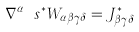Convert formula to latex. <formula><loc_0><loc_0><loc_500><loc_500>\nabla ^ { \alpha } \ s ^ { * } W _ { \alpha \beta \gamma \delta } = J ^ { * } _ { \beta \gamma \delta }</formula> 